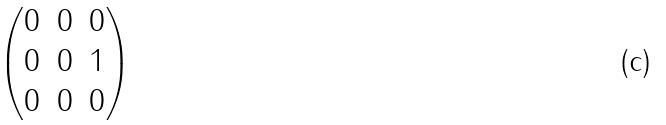<formula> <loc_0><loc_0><loc_500><loc_500>\begin{pmatrix} 0 & 0 & 0 \\ 0 & 0 & 1 \\ 0 & 0 & 0 \end{pmatrix}</formula> 